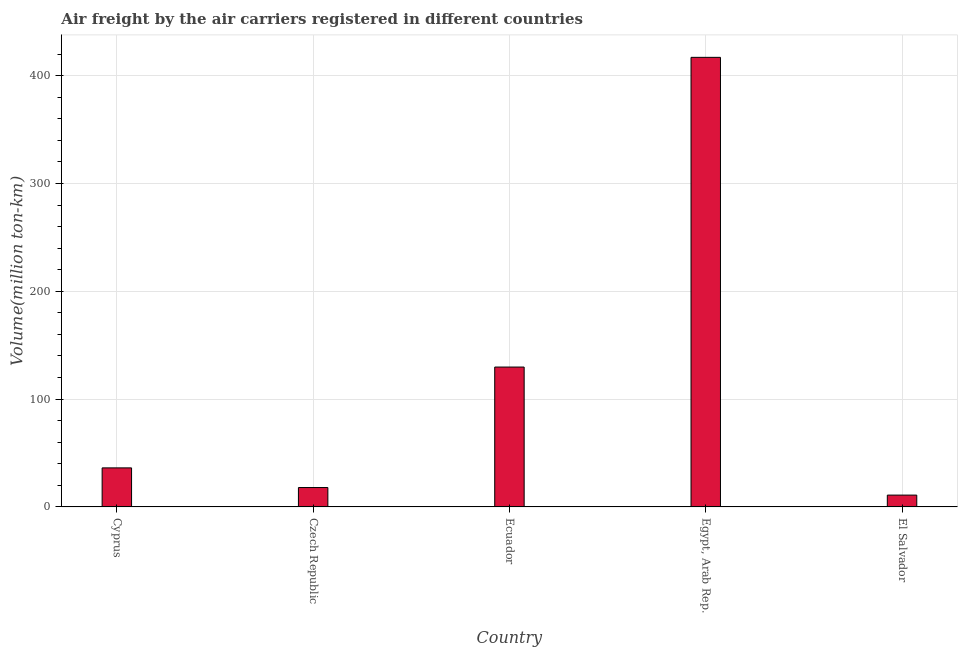What is the title of the graph?
Offer a very short reply. Air freight by the air carriers registered in different countries. What is the label or title of the X-axis?
Your answer should be compact. Country. What is the label or title of the Y-axis?
Offer a very short reply. Volume(million ton-km). What is the air freight in Ecuador?
Your answer should be compact. 129.73. Across all countries, what is the maximum air freight?
Give a very brief answer. 416.99. Across all countries, what is the minimum air freight?
Your response must be concise. 10.97. In which country was the air freight maximum?
Provide a short and direct response. Egypt, Arab Rep. In which country was the air freight minimum?
Your answer should be compact. El Salvador. What is the sum of the air freight?
Offer a terse response. 611.88. What is the difference between the air freight in Ecuador and Egypt, Arab Rep.?
Offer a very short reply. -287.25. What is the average air freight per country?
Ensure brevity in your answer.  122.38. What is the median air freight?
Give a very brief answer. 36.21. In how many countries, is the air freight greater than 380 million ton-km?
Give a very brief answer. 1. What is the ratio of the air freight in Cyprus to that in Ecuador?
Offer a very short reply. 0.28. Is the air freight in Cyprus less than that in Czech Republic?
Provide a succinct answer. No. Is the difference between the air freight in Czech Republic and Egypt, Arab Rep. greater than the difference between any two countries?
Give a very brief answer. No. What is the difference between the highest and the second highest air freight?
Keep it short and to the point. 287.25. Is the sum of the air freight in Cyprus and Ecuador greater than the maximum air freight across all countries?
Your response must be concise. No. What is the difference between the highest and the lowest air freight?
Give a very brief answer. 406.02. In how many countries, is the air freight greater than the average air freight taken over all countries?
Your response must be concise. 2. What is the Volume(million ton-km) of Cyprus?
Give a very brief answer. 36.21. What is the Volume(million ton-km) of Czech Republic?
Ensure brevity in your answer.  17.99. What is the Volume(million ton-km) of Ecuador?
Give a very brief answer. 129.73. What is the Volume(million ton-km) of Egypt, Arab Rep.?
Keep it short and to the point. 416.99. What is the Volume(million ton-km) of El Salvador?
Your answer should be compact. 10.97. What is the difference between the Volume(million ton-km) in Cyprus and Czech Republic?
Make the answer very short. 18.23. What is the difference between the Volume(million ton-km) in Cyprus and Ecuador?
Provide a short and direct response. -93.52. What is the difference between the Volume(million ton-km) in Cyprus and Egypt, Arab Rep.?
Your response must be concise. -380.77. What is the difference between the Volume(million ton-km) in Cyprus and El Salvador?
Ensure brevity in your answer.  25.25. What is the difference between the Volume(million ton-km) in Czech Republic and Ecuador?
Offer a terse response. -111.74. What is the difference between the Volume(million ton-km) in Czech Republic and Egypt, Arab Rep.?
Offer a very short reply. -399. What is the difference between the Volume(million ton-km) in Czech Republic and El Salvador?
Keep it short and to the point. 7.02. What is the difference between the Volume(million ton-km) in Ecuador and Egypt, Arab Rep.?
Give a very brief answer. -287.25. What is the difference between the Volume(million ton-km) in Ecuador and El Salvador?
Your answer should be very brief. 118.76. What is the difference between the Volume(million ton-km) in Egypt, Arab Rep. and El Salvador?
Keep it short and to the point. 406.02. What is the ratio of the Volume(million ton-km) in Cyprus to that in Czech Republic?
Provide a short and direct response. 2.01. What is the ratio of the Volume(million ton-km) in Cyprus to that in Ecuador?
Keep it short and to the point. 0.28. What is the ratio of the Volume(million ton-km) in Cyprus to that in Egypt, Arab Rep.?
Provide a succinct answer. 0.09. What is the ratio of the Volume(million ton-km) in Cyprus to that in El Salvador?
Offer a terse response. 3.3. What is the ratio of the Volume(million ton-km) in Czech Republic to that in Ecuador?
Your response must be concise. 0.14. What is the ratio of the Volume(million ton-km) in Czech Republic to that in Egypt, Arab Rep.?
Offer a very short reply. 0.04. What is the ratio of the Volume(million ton-km) in Czech Republic to that in El Salvador?
Your answer should be compact. 1.64. What is the ratio of the Volume(million ton-km) in Ecuador to that in Egypt, Arab Rep.?
Provide a succinct answer. 0.31. What is the ratio of the Volume(million ton-km) in Ecuador to that in El Salvador?
Offer a terse response. 11.83. What is the ratio of the Volume(million ton-km) in Egypt, Arab Rep. to that in El Salvador?
Your answer should be very brief. 38.02. 